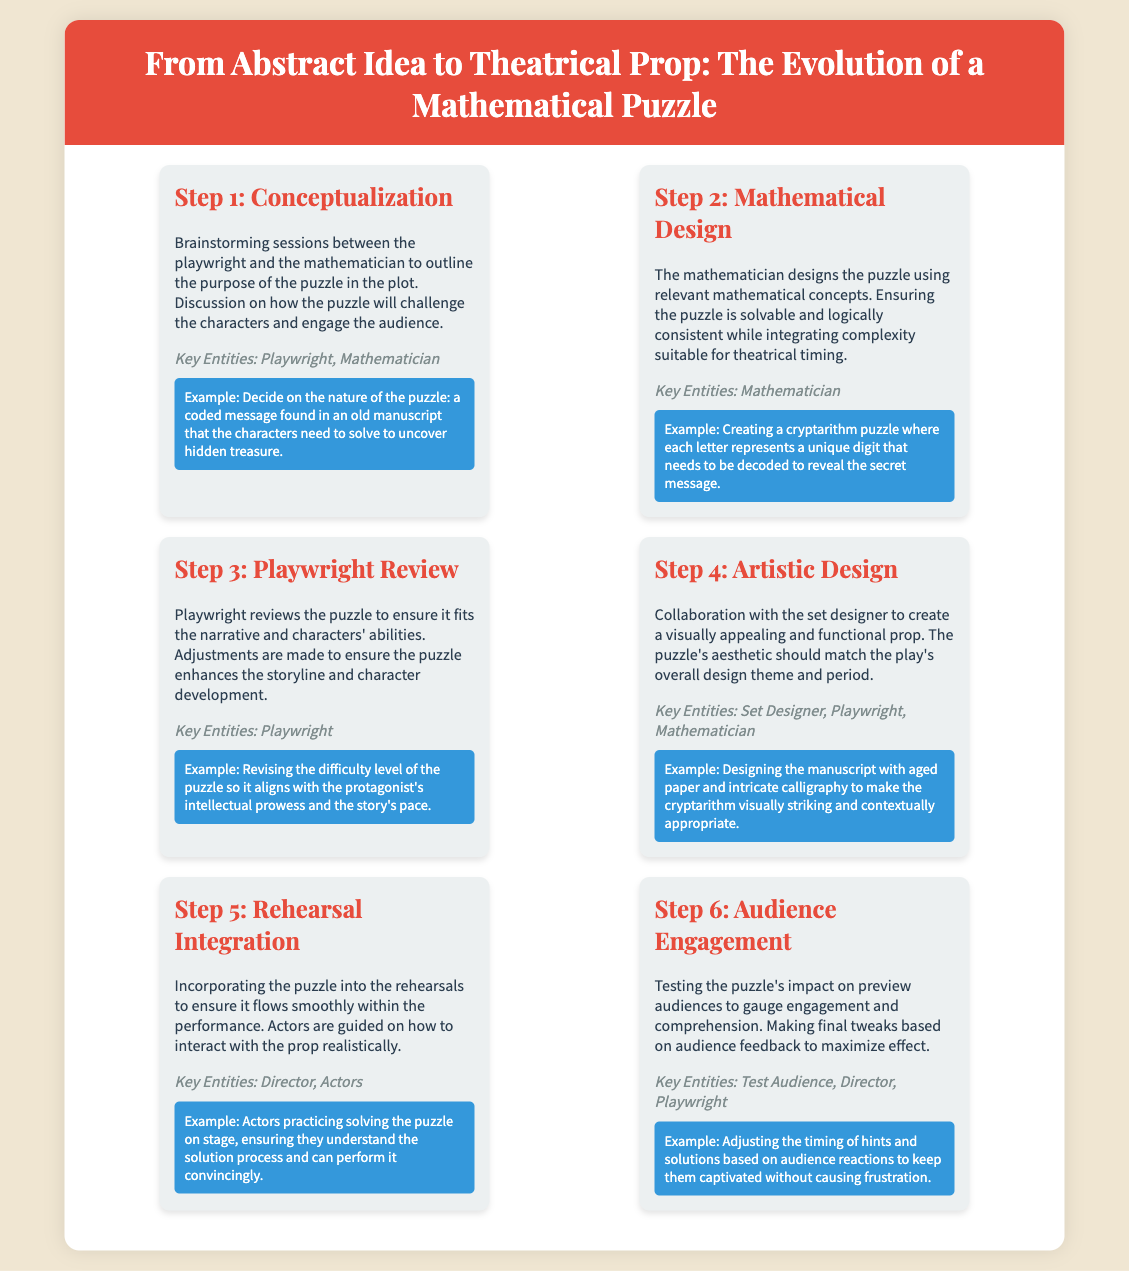What is the title of the infographic? The title is stated at the top of the document, which describes the evolution process of a mathematical puzzle in a theatrical context.
Answer: From Abstract Idea to Theatrical Prop: The Evolution of a Mathematical Puzzle Who collaborates during the conceptualization step? The key entities involved in this step are explicitly mentioned in the document.
Answer: Playwright, Mathematician What type of puzzle is designed in Step 2? The document describes the specific type of puzzle being designed in this step, which relates to the mathematical concepts being applied.
Answer: Cryptarithm puzzle What is the purpose of Step 5: Rehearsal Integration? The explanation provides insight into the focus of this step in relation to the puzzle and its presentation in the play.
Answer: Ensure it flows smoothly within the performance Which key entities are involved in the artistic design step? The document lists the key entities in this step, emphasizing their collaborative role in the design process.
Answer: Set Designer, Playwright, Mathematician What action is taken based on audience feedback in Step 6? The document describes the adjustment made in response to audience reactions, highlighting an essential aspect of the final testing phase.
Answer: Making final tweaks What is the example given in Step 4 for the artistic design? The document provides a specific example illustrating how the puzzle's visual aspect is enhanced through design choices.
Answer: Designing the manuscript with aged paper and intricate calligraphy 